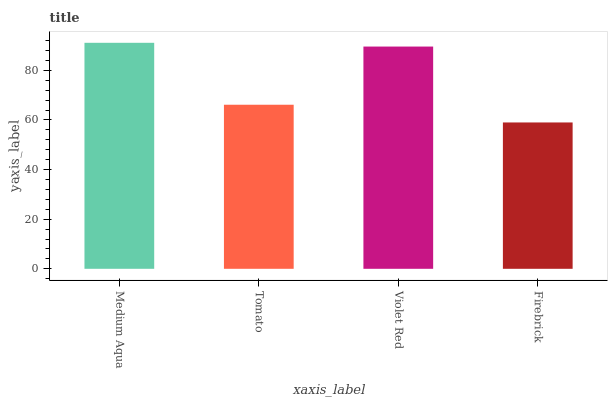Is Firebrick the minimum?
Answer yes or no. Yes. Is Medium Aqua the maximum?
Answer yes or no. Yes. Is Tomato the minimum?
Answer yes or no. No. Is Tomato the maximum?
Answer yes or no. No. Is Medium Aqua greater than Tomato?
Answer yes or no. Yes. Is Tomato less than Medium Aqua?
Answer yes or no. Yes. Is Tomato greater than Medium Aqua?
Answer yes or no. No. Is Medium Aqua less than Tomato?
Answer yes or no. No. Is Violet Red the high median?
Answer yes or no. Yes. Is Tomato the low median?
Answer yes or no. Yes. Is Medium Aqua the high median?
Answer yes or no. No. Is Violet Red the low median?
Answer yes or no. No. 